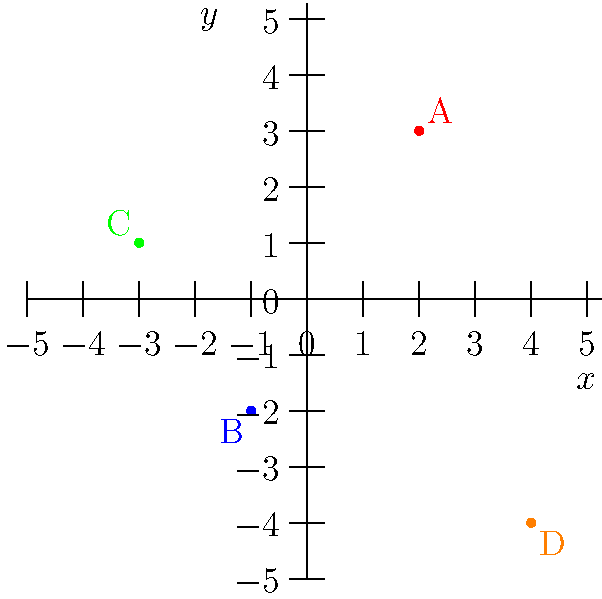In the 2D coordinate plane above, four points are plotted: A, B, C, and D. Which point is located in the third quadrant? To answer this question, we need to understand the quadrants of a 2D coordinate plane and how to identify them:

1. The coordinate plane is divided into four quadrants:
   - Quadrant I: Positive x, Positive y (top-right)
   - Quadrant II: Negative x, Positive y (top-left)
   - Quadrant III: Negative x, Negative y (bottom-left)
   - Quadrant IV: Positive x, Negative y (bottom-right)

2. Let's examine each point:
   - Point A: (2, 3) - This is in Quadrant I (positive x, positive y)
   - Point B: (-1, -2) - This is in Quadrant III (negative x, negative y)
   - Point C: (-3, 1) - This is in Quadrant II (negative x, positive y)
   - Point D: (4, -4) - This is in Quadrant IV (positive x, negative y)

3. The third quadrant is characterized by both x and y coordinates being negative.

4. Looking at the coordinates, we can see that only Point B (-1, -2) has both negative x and y coordinates.

Therefore, Point B is located in the third quadrant.
Answer: B 